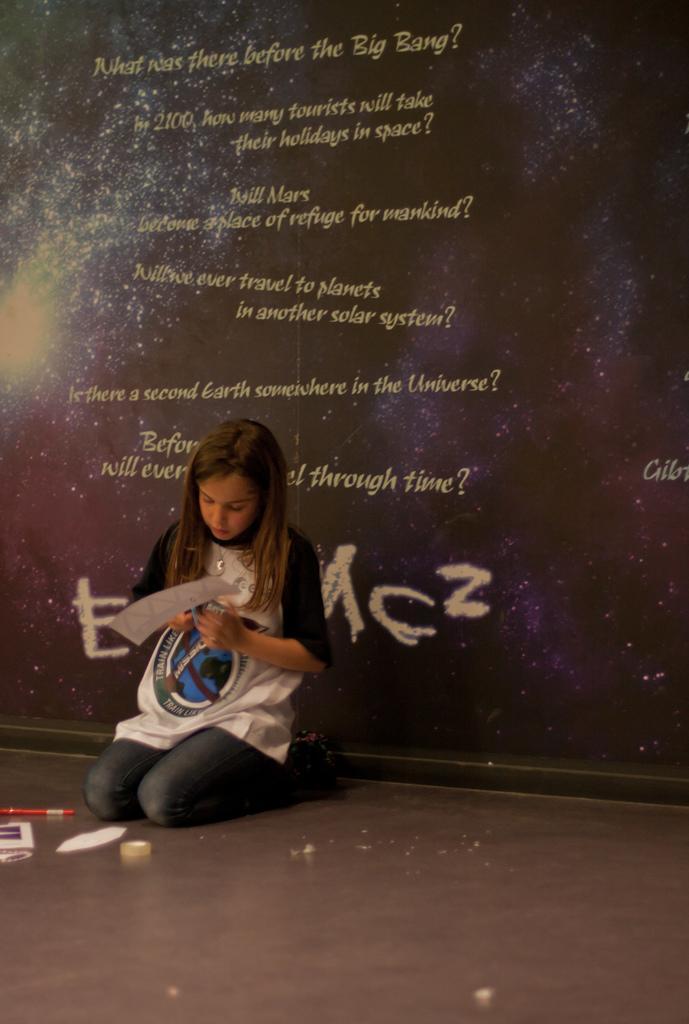Can you describe this image briefly? In this picture I can see a girl who is sitting in front of this image and I see she is holding a thing in her hands and I see few things in front of her and in the background I see the wall on which there is something written. 